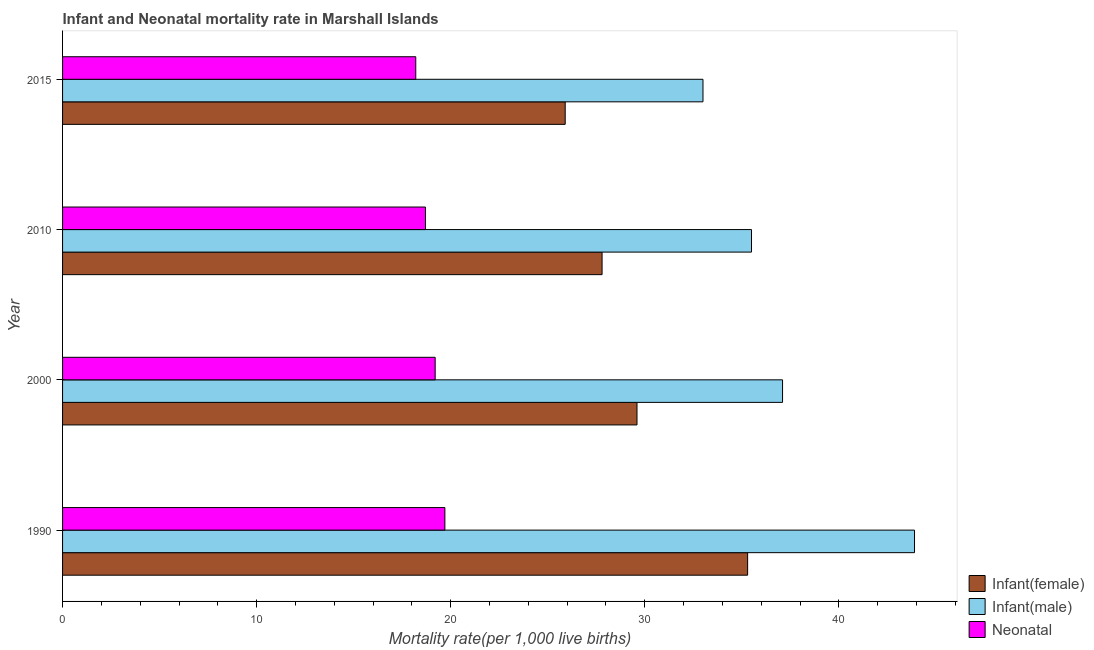Are the number of bars per tick equal to the number of legend labels?
Your response must be concise. Yes. How many bars are there on the 1st tick from the bottom?
Provide a short and direct response. 3. In how many cases, is the number of bars for a given year not equal to the number of legend labels?
Your answer should be very brief. 0. What is the infant mortality rate(male) in 2000?
Make the answer very short. 37.1. Across all years, what is the maximum neonatal mortality rate?
Your answer should be compact. 19.7. Across all years, what is the minimum infant mortality rate(male)?
Offer a terse response. 33. In which year was the infant mortality rate(female) maximum?
Provide a succinct answer. 1990. In which year was the infant mortality rate(female) minimum?
Keep it short and to the point. 2015. What is the total neonatal mortality rate in the graph?
Offer a very short reply. 75.8. What is the difference between the infant mortality rate(female) in 1990 and the infant mortality rate(male) in 2015?
Give a very brief answer. 2.3. What is the average infant mortality rate(female) per year?
Keep it short and to the point. 29.65. In the year 2015, what is the difference between the infant mortality rate(male) and infant mortality rate(female)?
Give a very brief answer. 7.1. Is the neonatal mortality rate in 2010 less than that in 2015?
Provide a succinct answer. No. What is the difference between the highest and the second highest neonatal mortality rate?
Your response must be concise. 0.5. What does the 1st bar from the top in 1990 represents?
Your answer should be compact. Neonatal . What does the 2nd bar from the bottom in 2015 represents?
Offer a very short reply. Infant(male). Is it the case that in every year, the sum of the infant mortality rate(female) and infant mortality rate(male) is greater than the neonatal mortality rate?
Your answer should be very brief. Yes. How many bars are there?
Make the answer very short. 12. How many years are there in the graph?
Provide a short and direct response. 4. Does the graph contain any zero values?
Your answer should be compact. No. How are the legend labels stacked?
Give a very brief answer. Vertical. What is the title of the graph?
Make the answer very short. Infant and Neonatal mortality rate in Marshall Islands. What is the label or title of the X-axis?
Give a very brief answer. Mortality rate(per 1,0 live births). What is the Mortality rate(per 1,000 live births) in Infant(female) in 1990?
Offer a terse response. 35.3. What is the Mortality rate(per 1,000 live births) in Infant(male) in 1990?
Give a very brief answer. 43.9. What is the Mortality rate(per 1,000 live births) of Infant(female) in 2000?
Provide a short and direct response. 29.6. What is the Mortality rate(per 1,000 live births) in Infant(male) in 2000?
Ensure brevity in your answer.  37.1. What is the Mortality rate(per 1,000 live births) of Infant(female) in 2010?
Your response must be concise. 27.8. What is the Mortality rate(per 1,000 live births) in Infant(male) in 2010?
Offer a very short reply. 35.5. What is the Mortality rate(per 1,000 live births) in Infant(female) in 2015?
Your answer should be compact. 25.9. What is the Mortality rate(per 1,000 live births) in Infant(male) in 2015?
Provide a succinct answer. 33. Across all years, what is the maximum Mortality rate(per 1,000 live births) in Infant(female)?
Keep it short and to the point. 35.3. Across all years, what is the maximum Mortality rate(per 1,000 live births) of Infant(male)?
Make the answer very short. 43.9. Across all years, what is the minimum Mortality rate(per 1,000 live births) of Infant(female)?
Your response must be concise. 25.9. Across all years, what is the minimum Mortality rate(per 1,000 live births) in Infant(male)?
Offer a terse response. 33. Across all years, what is the minimum Mortality rate(per 1,000 live births) in Neonatal ?
Your answer should be compact. 18.2. What is the total Mortality rate(per 1,000 live births) in Infant(female) in the graph?
Your answer should be compact. 118.6. What is the total Mortality rate(per 1,000 live births) of Infant(male) in the graph?
Make the answer very short. 149.5. What is the total Mortality rate(per 1,000 live births) in Neonatal  in the graph?
Ensure brevity in your answer.  75.8. What is the difference between the Mortality rate(per 1,000 live births) of Infant(female) in 1990 and that in 2000?
Provide a succinct answer. 5.7. What is the difference between the Mortality rate(per 1,000 live births) in Infant(male) in 1990 and that in 2000?
Provide a succinct answer. 6.8. What is the difference between the Mortality rate(per 1,000 live births) in Neonatal  in 1990 and that in 2000?
Your answer should be very brief. 0.5. What is the difference between the Mortality rate(per 1,000 live births) of Infant(female) in 1990 and that in 2015?
Your answer should be compact. 9.4. What is the difference between the Mortality rate(per 1,000 live births) in Infant(male) in 1990 and that in 2015?
Ensure brevity in your answer.  10.9. What is the difference between the Mortality rate(per 1,000 live births) of Neonatal  in 1990 and that in 2015?
Your answer should be very brief. 1.5. What is the difference between the Mortality rate(per 1,000 live births) of Infant(female) in 2000 and that in 2010?
Provide a short and direct response. 1.8. What is the difference between the Mortality rate(per 1,000 live births) of Infant(male) in 2000 and that in 2010?
Your answer should be compact. 1.6. What is the difference between the Mortality rate(per 1,000 live births) in Infant(female) in 2000 and that in 2015?
Offer a terse response. 3.7. What is the difference between the Mortality rate(per 1,000 live births) of Infant(male) in 2000 and that in 2015?
Ensure brevity in your answer.  4.1. What is the difference between the Mortality rate(per 1,000 live births) of Neonatal  in 2000 and that in 2015?
Ensure brevity in your answer.  1. What is the difference between the Mortality rate(per 1,000 live births) in Infant(female) in 2010 and that in 2015?
Provide a short and direct response. 1.9. What is the difference between the Mortality rate(per 1,000 live births) of Infant(female) in 1990 and the Mortality rate(per 1,000 live births) of Neonatal  in 2000?
Offer a terse response. 16.1. What is the difference between the Mortality rate(per 1,000 live births) of Infant(male) in 1990 and the Mortality rate(per 1,000 live births) of Neonatal  in 2000?
Your response must be concise. 24.7. What is the difference between the Mortality rate(per 1,000 live births) of Infant(female) in 1990 and the Mortality rate(per 1,000 live births) of Neonatal  in 2010?
Provide a short and direct response. 16.6. What is the difference between the Mortality rate(per 1,000 live births) in Infant(male) in 1990 and the Mortality rate(per 1,000 live births) in Neonatal  in 2010?
Give a very brief answer. 25.2. What is the difference between the Mortality rate(per 1,000 live births) in Infant(male) in 1990 and the Mortality rate(per 1,000 live births) in Neonatal  in 2015?
Make the answer very short. 25.7. What is the difference between the Mortality rate(per 1,000 live births) of Infant(female) in 2000 and the Mortality rate(per 1,000 live births) of Infant(male) in 2010?
Provide a short and direct response. -5.9. What is the difference between the Mortality rate(per 1,000 live births) of Infant(female) in 2000 and the Mortality rate(per 1,000 live births) of Neonatal  in 2010?
Ensure brevity in your answer.  10.9. What is the difference between the Mortality rate(per 1,000 live births) of Infant(male) in 2000 and the Mortality rate(per 1,000 live births) of Neonatal  in 2010?
Provide a short and direct response. 18.4. What is the difference between the Mortality rate(per 1,000 live births) in Infant(male) in 2000 and the Mortality rate(per 1,000 live births) in Neonatal  in 2015?
Make the answer very short. 18.9. What is the difference between the Mortality rate(per 1,000 live births) in Infant(female) in 2010 and the Mortality rate(per 1,000 live births) in Infant(male) in 2015?
Provide a succinct answer. -5.2. What is the average Mortality rate(per 1,000 live births) of Infant(female) per year?
Give a very brief answer. 29.65. What is the average Mortality rate(per 1,000 live births) in Infant(male) per year?
Offer a terse response. 37.38. What is the average Mortality rate(per 1,000 live births) of Neonatal  per year?
Ensure brevity in your answer.  18.95. In the year 1990, what is the difference between the Mortality rate(per 1,000 live births) in Infant(male) and Mortality rate(per 1,000 live births) in Neonatal ?
Provide a short and direct response. 24.2. In the year 2000, what is the difference between the Mortality rate(per 1,000 live births) of Infant(female) and Mortality rate(per 1,000 live births) of Infant(male)?
Make the answer very short. -7.5. In the year 2010, what is the difference between the Mortality rate(per 1,000 live births) of Infant(female) and Mortality rate(per 1,000 live births) of Neonatal ?
Ensure brevity in your answer.  9.1. In the year 2010, what is the difference between the Mortality rate(per 1,000 live births) in Infant(male) and Mortality rate(per 1,000 live births) in Neonatal ?
Ensure brevity in your answer.  16.8. In the year 2015, what is the difference between the Mortality rate(per 1,000 live births) of Infant(female) and Mortality rate(per 1,000 live births) of Infant(male)?
Your response must be concise. -7.1. What is the ratio of the Mortality rate(per 1,000 live births) in Infant(female) in 1990 to that in 2000?
Offer a terse response. 1.19. What is the ratio of the Mortality rate(per 1,000 live births) in Infant(male) in 1990 to that in 2000?
Ensure brevity in your answer.  1.18. What is the ratio of the Mortality rate(per 1,000 live births) in Infant(female) in 1990 to that in 2010?
Your answer should be compact. 1.27. What is the ratio of the Mortality rate(per 1,000 live births) of Infant(male) in 1990 to that in 2010?
Provide a succinct answer. 1.24. What is the ratio of the Mortality rate(per 1,000 live births) of Neonatal  in 1990 to that in 2010?
Offer a very short reply. 1.05. What is the ratio of the Mortality rate(per 1,000 live births) of Infant(female) in 1990 to that in 2015?
Give a very brief answer. 1.36. What is the ratio of the Mortality rate(per 1,000 live births) in Infant(male) in 1990 to that in 2015?
Offer a very short reply. 1.33. What is the ratio of the Mortality rate(per 1,000 live births) in Neonatal  in 1990 to that in 2015?
Your response must be concise. 1.08. What is the ratio of the Mortality rate(per 1,000 live births) in Infant(female) in 2000 to that in 2010?
Ensure brevity in your answer.  1.06. What is the ratio of the Mortality rate(per 1,000 live births) of Infant(male) in 2000 to that in 2010?
Offer a terse response. 1.05. What is the ratio of the Mortality rate(per 1,000 live births) of Neonatal  in 2000 to that in 2010?
Ensure brevity in your answer.  1.03. What is the ratio of the Mortality rate(per 1,000 live births) of Infant(female) in 2000 to that in 2015?
Offer a very short reply. 1.14. What is the ratio of the Mortality rate(per 1,000 live births) in Infant(male) in 2000 to that in 2015?
Make the answer very short. 1.12. What is the ratio of the Mortality rate(per 1,000 live births) of Neonatal  in 2000 to that in 2015?
Make the answer very short. 1.05. What is the ratio of the Mortality rate(per 1,000 live births) in Infant(female) in 2010 to that in 2015?
Make the answer very short. 1.07. What is the ratio of the Mortality rate(per 1,000 live births) of Infant(male) in 2010 to that in 2015?
Your answer should be compact. 1.08. What is the ratio of the Mortality rate(per 1,000 live births) of Neonatal  in 2010 to that in 2015?
Make the answer very short. 1.03. What is the difference between the highest and the lowest Mortality rate(per 1,000 live births) of Infant(female)?
Ensure brevity in your answer.  9.4. What is the difference between the highest and the lowest Mortality rate(per 1,000 live births) of Infant(male)?
Give a very brief answer. 10.9. What is the difference between the highest and the lowest Mortality rate(per 1,000 live births) in Neonatal ?
Provide a succinct answer. 1.5. 